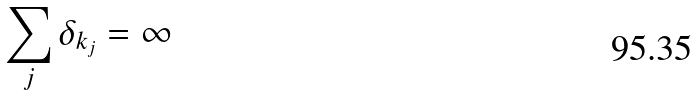<formula> <loc_0><loc_0><loc_500><loc_500>\sum _ { j } \delta _ { k _ { j } } = \infty</formula> 